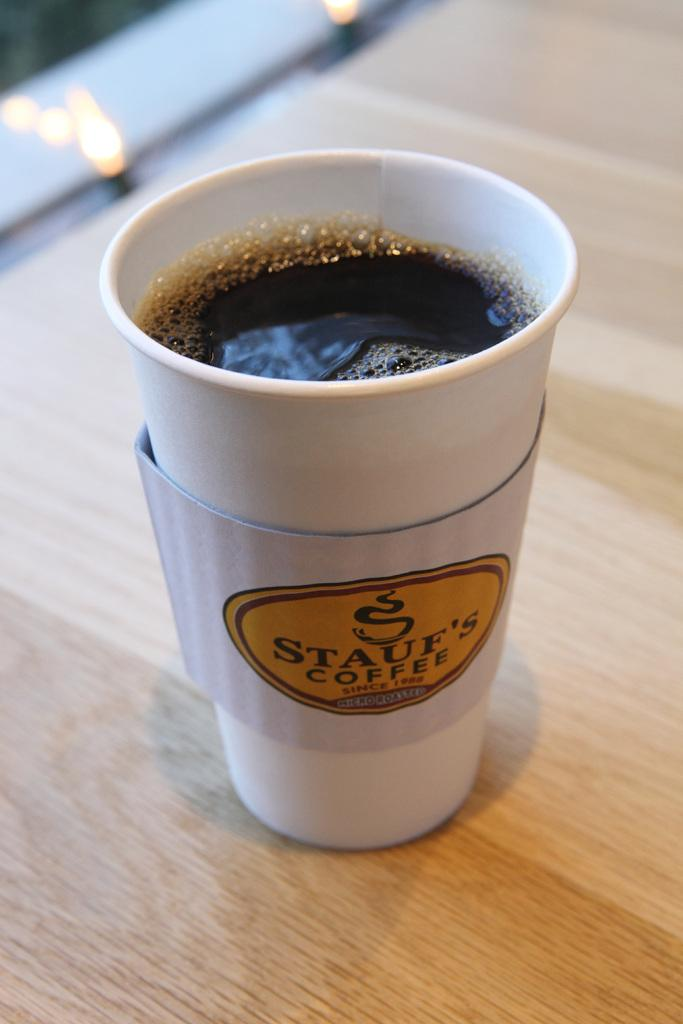What type of container is visible in the image? There is a white color paper cup in the image. What is inside the container? The cup contains a drink. Is there any additional information on the cup? Yes, there is a label on the cup. What is the surface on which the cup is placed? The cup is placed on a wooden surface. Can you describe the background of the image? The background of the image is blurred. What type of knowledge can be gained from the polish on the cup in the image? There is no polish on the cup in the image, and therefore no knowledge can be gained from it. 